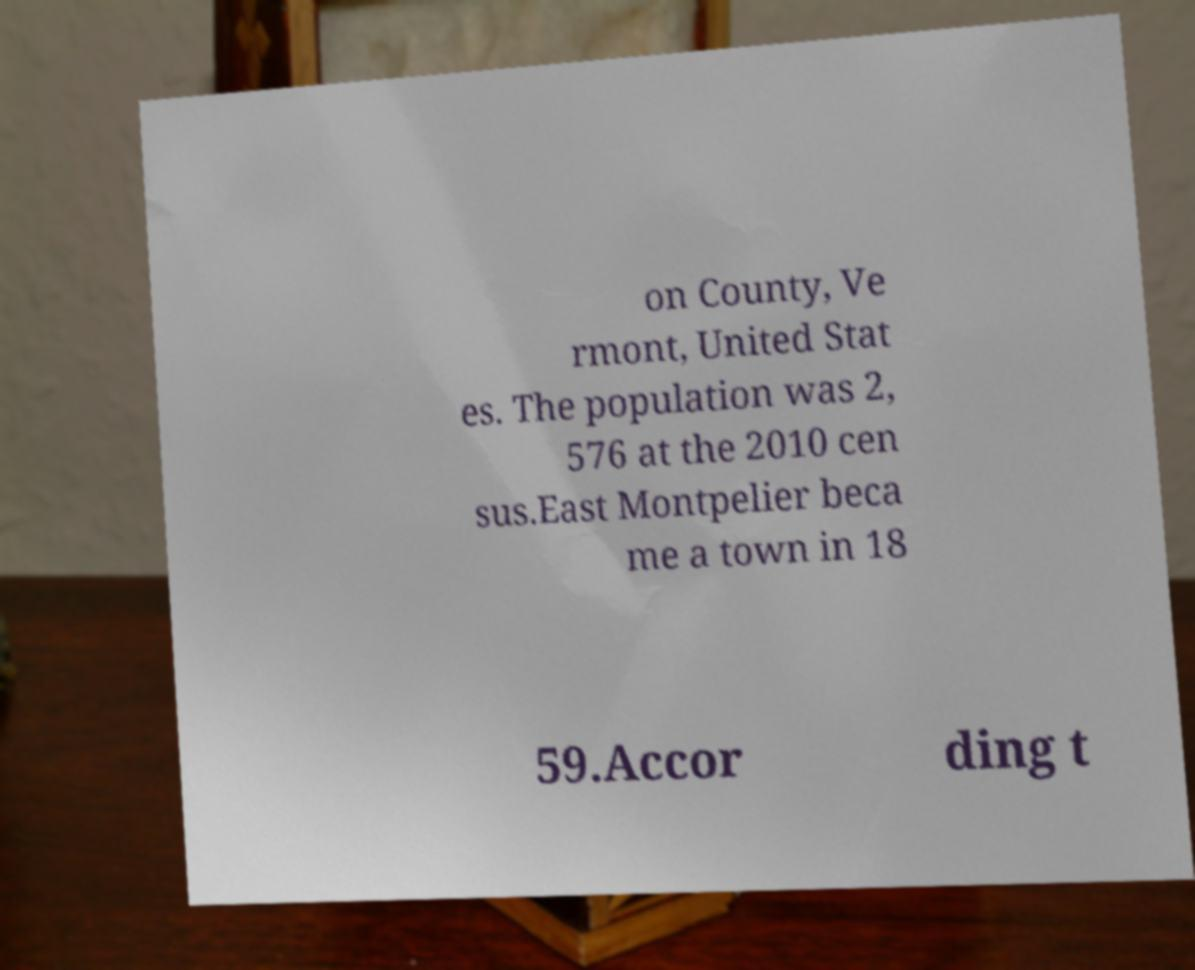There's text embedded in this image that I need extracted. Can you transcribe it verbatim? on County, Ve rmont, United Stat es. The population was 2, 576 at the 2010 cen sus.East Montpelier beca me a town in 18 59.Accor ding t 